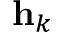<formula> <loc_0><loc_0><loc_500><loc_500>{ h } _ { k }</formula> 